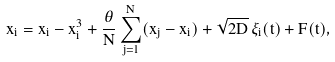<formula> <loc_0><loc_0><loc_500><loc_500>\dot { x } _ { i } = x _ { i } - x _ { i } ^ { 3 } + \frac { \theta } { N } \sum _ { j = 1 } ^ { N } ( x _ { j } - x _ { i } ) + \sqrt { 2 D } \, \xi _ { i } ( t ) + F ( t ) ,</formula> 